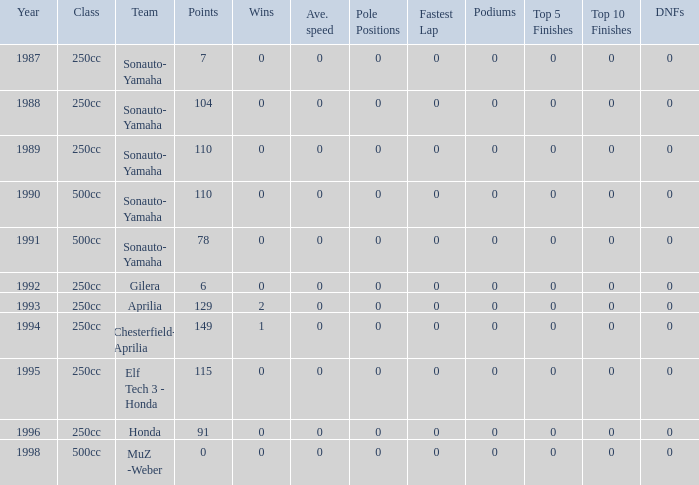What is the highest number of points the team with 0 wins had before 1992? 110.0. 